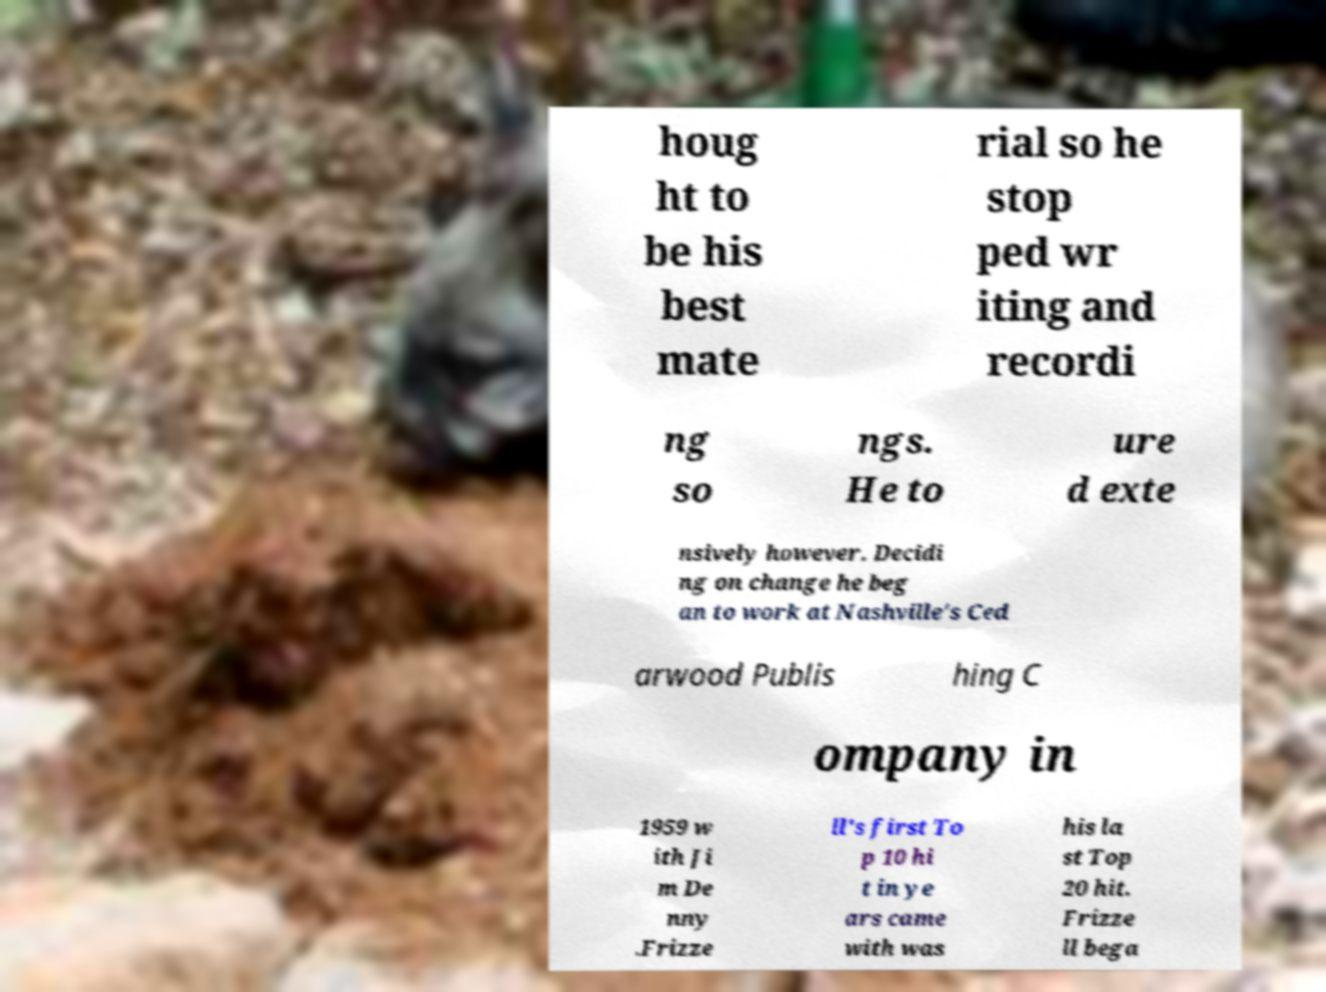Could you assist in decoding the text presented in this image and type it out clearly? houg ht to be his best mate rial so he stop ped wr iting and recordi ng so ngs. He to ure d exte nsively however. Decidi ng on change he beg an to work at Nashville's Ced arwood Publis hing C ompany in 1959 w ith Ji m De nny .Frizze ll's first To p 10 hi t in ye ars came with was his la st Top 20 hit. Frizze ll bega 